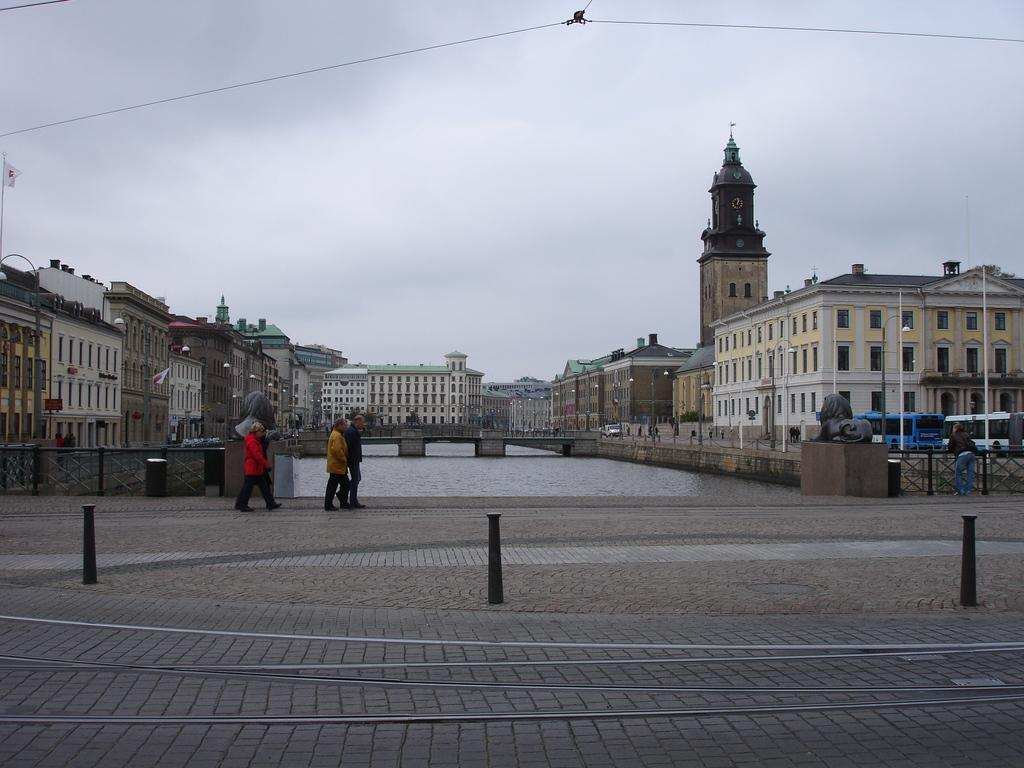What type of structures can be seen in the image? There are buildings in the image. What else is present in the image besides buildings? There are vehicles and people visible in the image. What natural feature can be seen in the image? There is a lake visible in the image. How many rabbits can be seen in the image? There are no rabbits present in the image. What type of root is growing near the lake in the image? There is no root visible in the image, as it only shows buildings, vehicles, people, and a lake. 